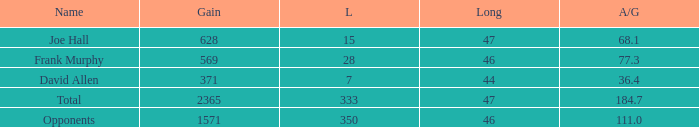How much Loss has a Gain smaller than 1571, and a Long smaller than 47, and an Avg/G of 36.4? 1.0. 